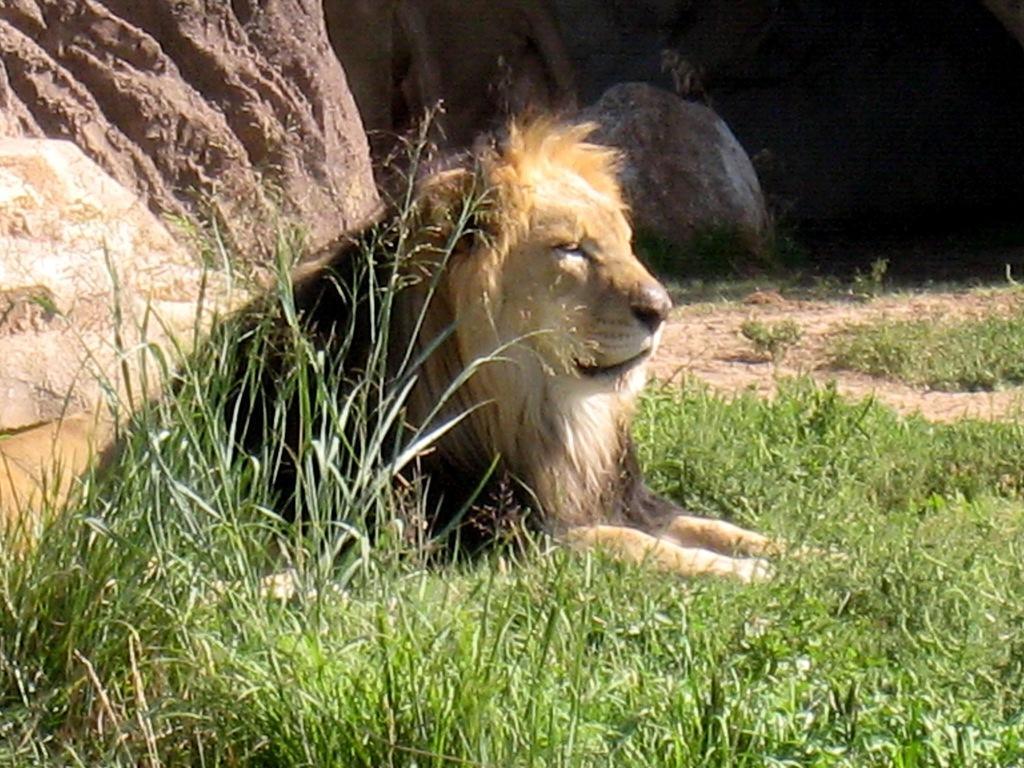In one or two sentences, can you explain what this image depicts? This is the picture of a lion which is on the grass floor and behind there are some rocks. 